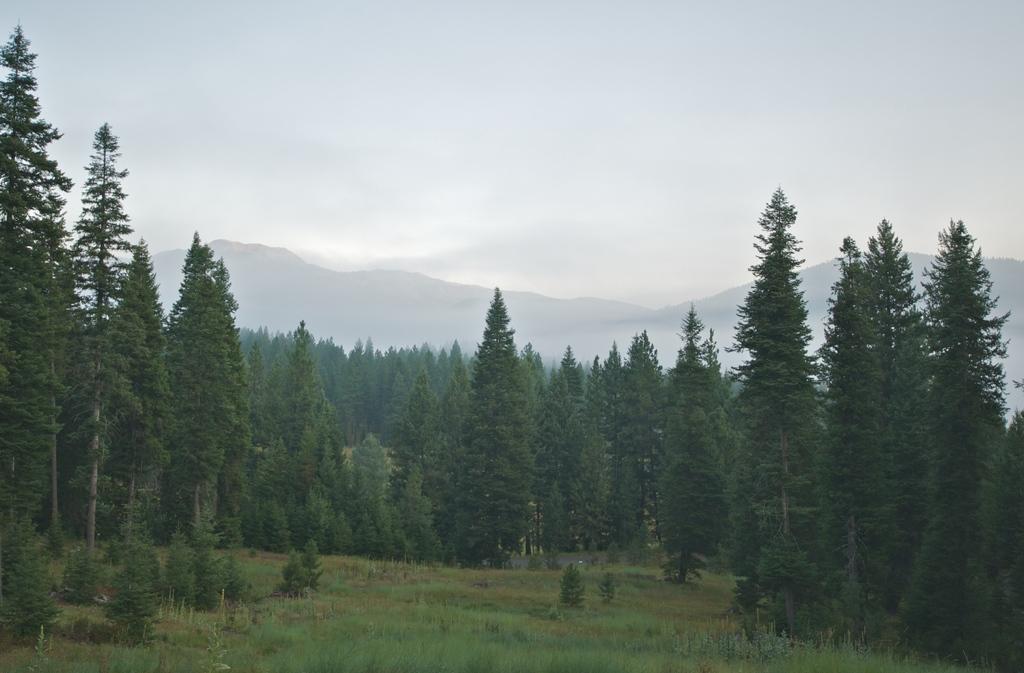How would you summarize this image in a sentence or two? In this image I can see number of trees, grass, mountains and the sky. 